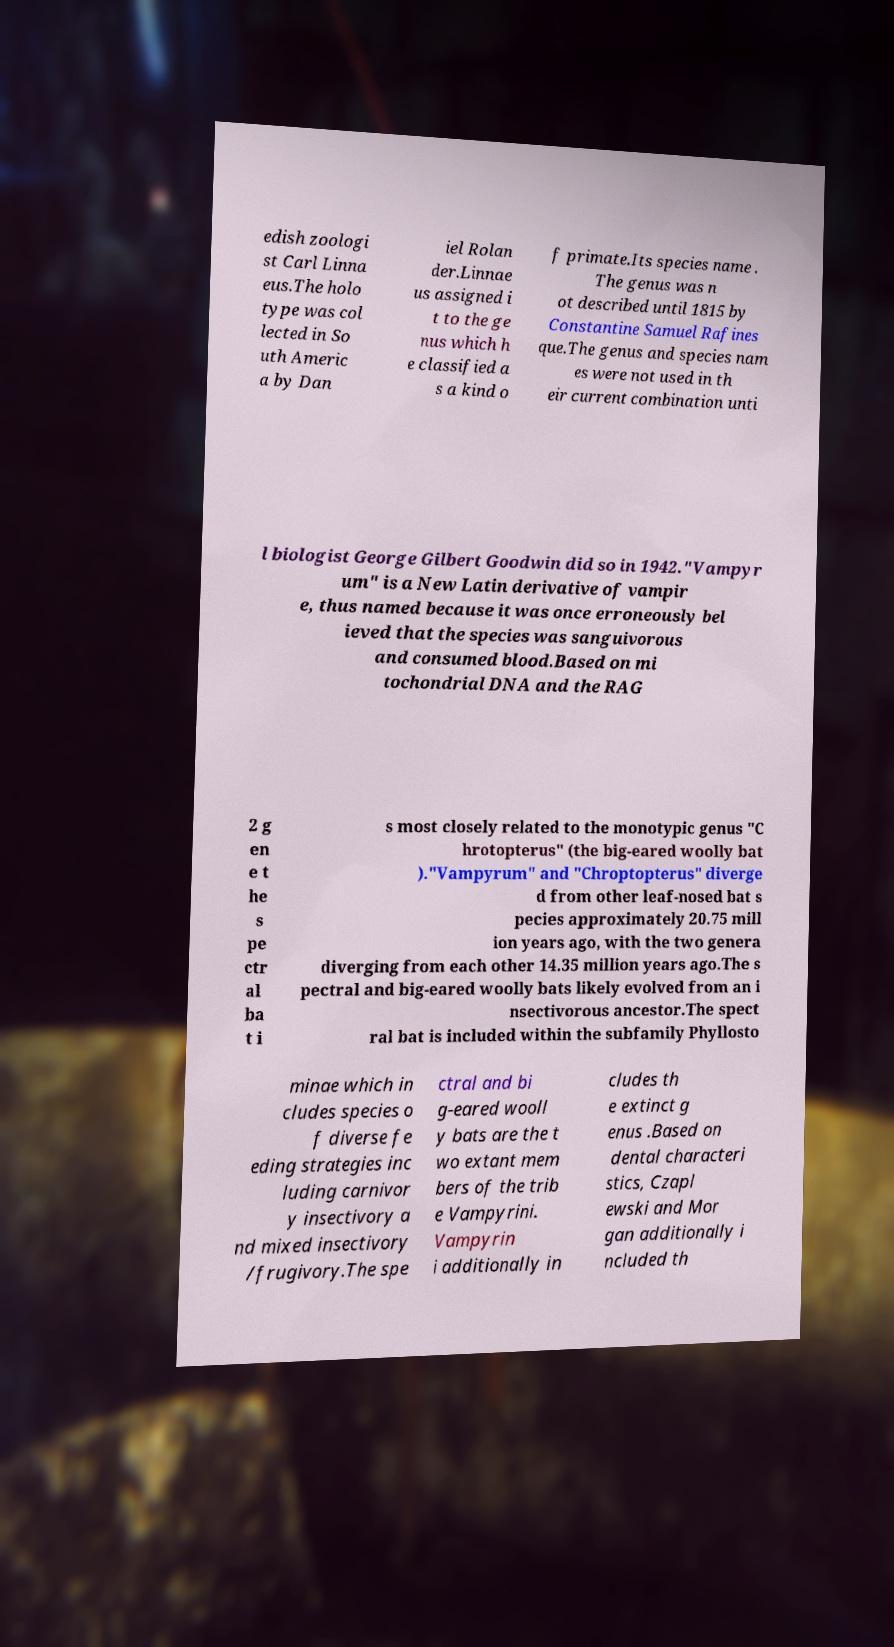I need the written content from this picture converted into text. Can you do that? edish zoologi st Carl Linna eus.The holo type was col lected in So uth Americ a by Dan iel Rolan der.Linnae us assigned i t to the ge nus which h e classified a s a kind o f primate.Its species name . The genus was n ot described until 1815 by Constantine Samuel Rafines que.The genus and species nam es were not used in th eir current combination unti l biologist George Gilbert Goodwin did so in 1942."Vampyr um" is a New Latin derivative of vampir e, thus named because it was once erroneously bel ieved that the species was sanguivorous and consumed blood.Based on mi tochondrial DNA and the RAG 2 g en e t he s pe ctr al ba t i s most closely related to the monotypic genus "C hrotopterus" (the big-eared woolly bat )."Vampyrum" and "Chroptopterus" diverge d from other leaf-nosed bat s pecies approximately 20.75 mill ion years ago, with the two genera diverging from each other 14.35 million years ago.The s pectral and big-eared woolly bats likely evolved from an i nsectivorous ancestor.The spect ral bat is included within the subfamily Phyllosto minae which in cludes species o f diverse fe eding strategies inc luding carnivor y insectivory a nd mixed insectivory /frugivory.The spe ctral and bi g-eared wooll y bats are the t wo extant mem bers of the trib e Vampyrini. Vampyrin i additionally in cludes th e extinct g enus .Based on dental characteri stics, Czapl ewski and Mor gan additionally i ncluded th 